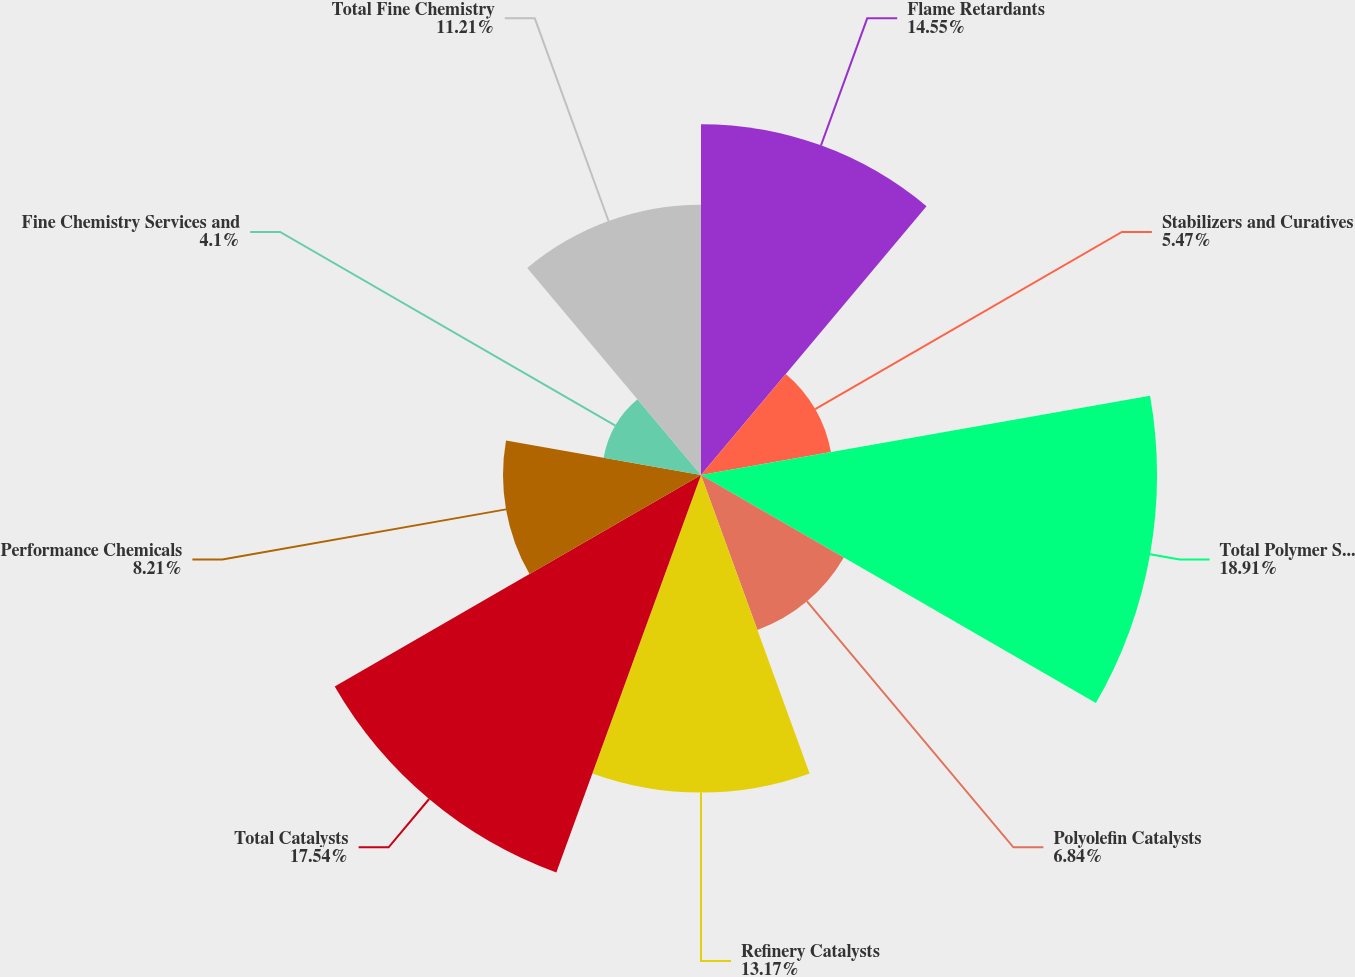Convert chart. <chart><loc_0><loc_0><loc_500><loc_500><pie_chart><fcel>Flame Retardants<fcel>Stabilizers and Curatives<fcel>Total Polymer Solutions<fcel>Polyolefin Catalysts<fcel>Refinery Catalysts<fcel>Total Catalysts<fcel>Performance Chemicals<fcel>Fine Chemistry Services and<fcel>Total Fine Chemistry<nl><fcel>14.55%<fcel>5.47%<fcel>18.91%<fcel>6.84%<fcel>13.17%<fcel>17.54%<fcel>8.21%<fcel>4.1%<fcel>11.21%<nl></chart> 